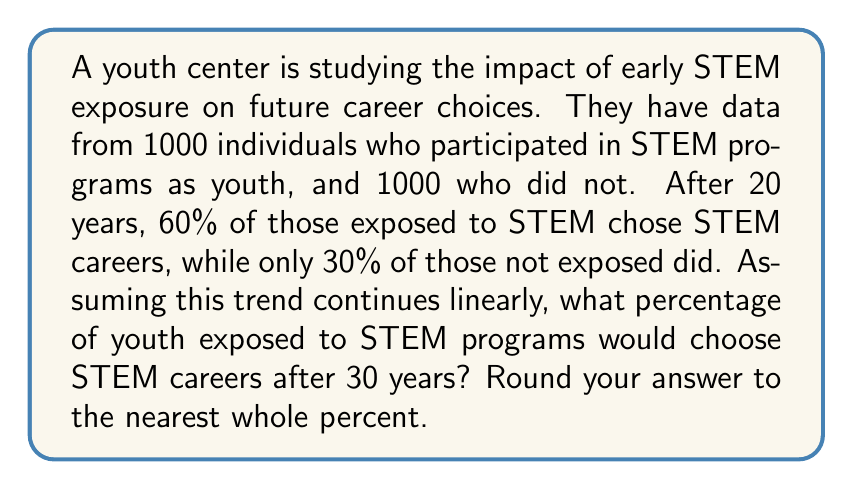Help me with this question. Let's approach this step-by-step:

1) First, we need to identify the rate of change in STEM career choice over time.

2) We know that after 20 years:
   - 60% of those exposed to STEM chose STEM careers
   - 30% of those not exposed chose STEM careers

3) The difference is 60% - 30% = 30% over 20 years

4) To find the rate of change per year, we divide:
   $$ \text{Rate} = \frac{30\%}{20 \text{ years}} = 1.5\% \text{ per year} $$

5) Now, we want to predict the percentage after 30 years. That's 10 more years than our initial data point.

6) The increase over these 10 years would be:
   $$ 10 \text{ years} \times 1.5\% \text{ per year} = 15\% $$

7) We add this to our initial percentage for those exposed to STEM:
   $$ 60\% + 15\% = 75\% $$

8) Rounding to the nearest whole percent, we get 75%.
Answer: 75% 